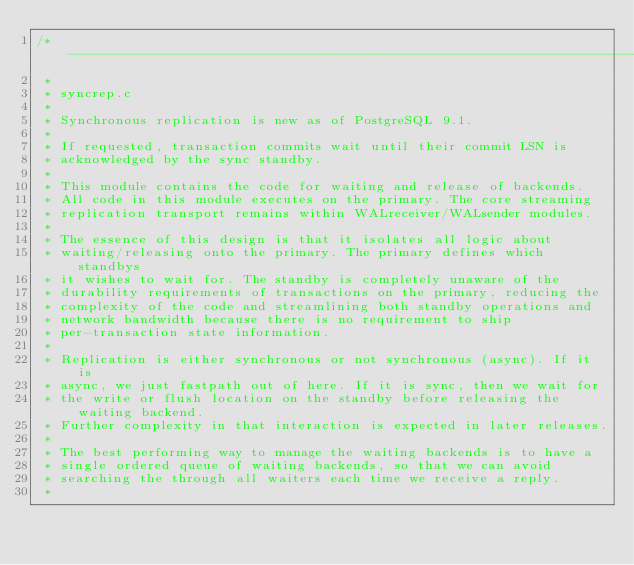<code> <loc_0><loc_0><loc_500><loc_500><_C_>/*-------------------------------------------------------------------------
 *
 * syncrep.c
 *
 * Synchronous replication is new as of PostgreSQL 9.1.
 *
 * If requested, transaction commits wait until their commit LSN is
 * acknowledged by the sync standby.
 *
 * This module contains the code for waiting and release of backends.
 * All code in this module executes on the primary. The core streaming
 * replication transport remains within WALreceiver/WALsender modules.
 *
 * The essence of this design is that it isolates all logic about
 * waiting/releasing onto the primary. The primary defines which standbys
 * it wishes to wait for. The standby is completely unaware of the
 * durability requirements of transactions on the primary, reducing the
 * complexity of the code and streamlining both standby operations and
 * network bandwidth because there is no requirement to ship
 * per-transaction state information.
 *
 * Replication is either synchronous or not synchronous (async). If it is
 * async, we just fastpath out of here. If it is sync, then we wait for
 * the write or flush location on the standby before releasing the waiting backend.
 * Further complexity in that interaction is expected in later releases.
 *
 * The best performing way to manage the waiting backends is to have a
 * single ordered queue of waiting backends, so that we can avoid
 * searching the through all waiters each time we receive a reply.
 *</code> 